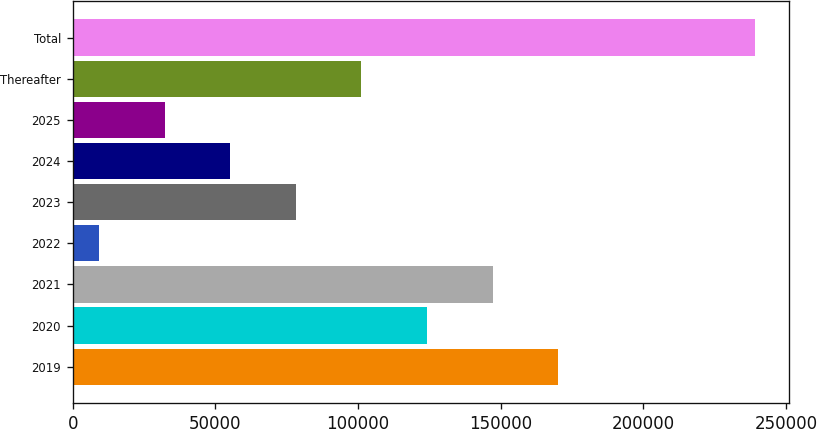<chart> <loc_0><loc_0><loc_500><loc_500><bar_chart><fcel>2019<fcel>2020<fcel>2021<fcel>2022<fcel>2023<fcel>2024<fcel>2025<fcel>Thereafter<fcel>Total<nl><fcel>170267<fcel>124256<fcel>147262<fcel>9231<fcel>78246.3<fcel>55241.2<fcel>32236.1<fcel>101251<fcel>239282<nl></chart> 